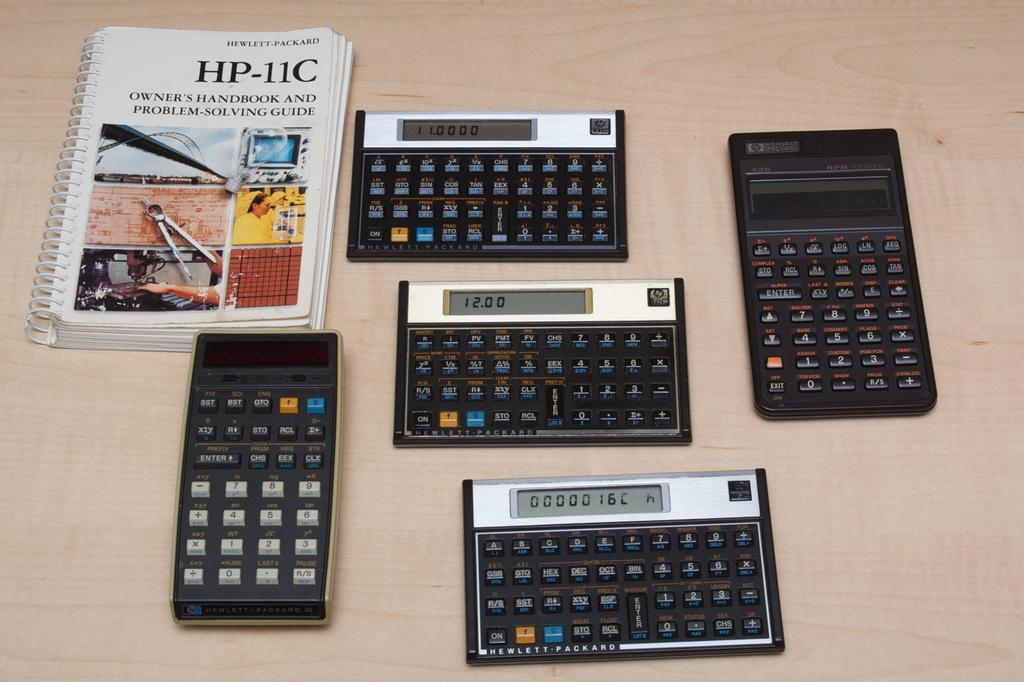<image>
Summarize the visual content of the image. Four Hewlett Packard digital calculators with a user manual. 